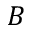<formula> <loc_0><loc_0><loc_500><loc_500>B</formula> 